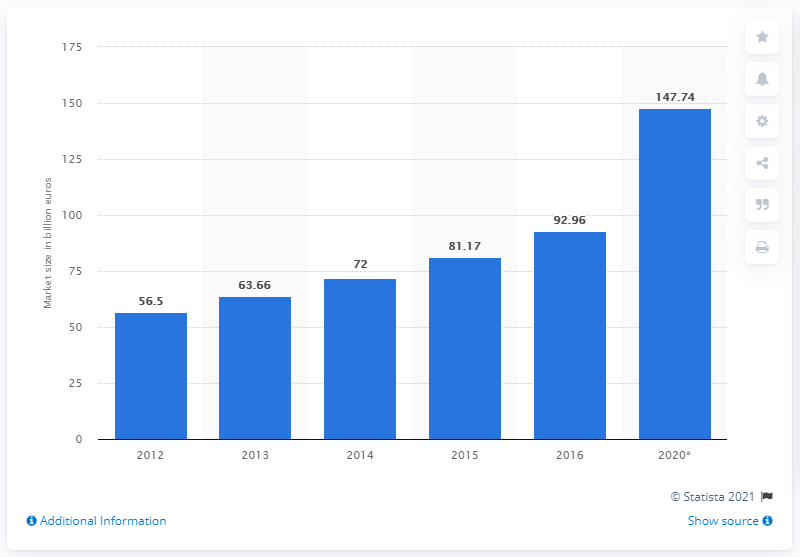Mention a couple of crucial points in this snapshot. In 2016, the express and small parcels market in Asia Pacific had a size of approximately 92.96. 